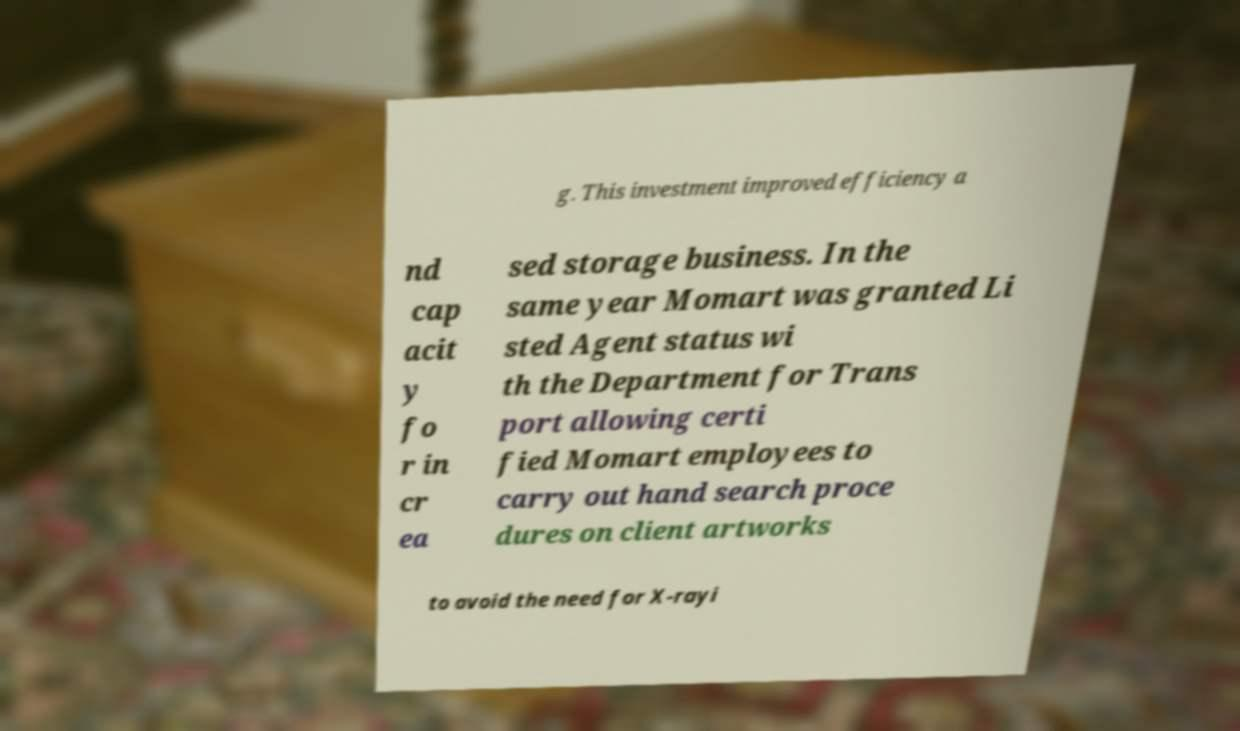Could you assist in decoding the text presented in this image and type it out clearly? g. This investment improved efficiency a nd cap acit y fo r in cr ea sed storage business. In the same year Momart was granted Li sted Agent status wi th the Department for Trans port allowing certi fied Momart employees to carry out hand search proce dures on client artworks to avoid the need for X-rayi 